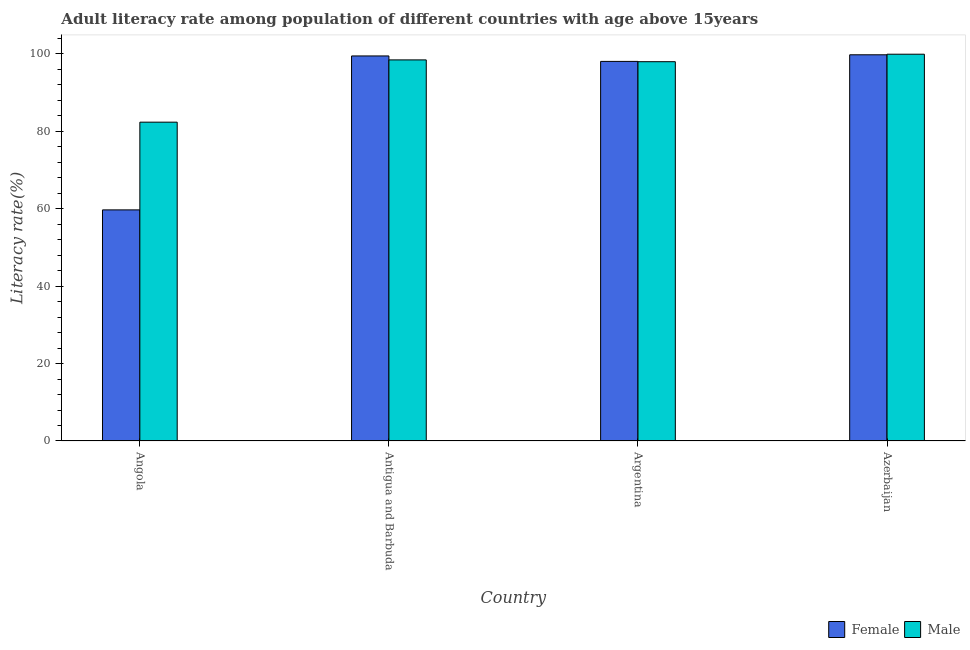How many different coloured bars are there?
Provide a succinct answer. 2. How many groups of bars are there?
Your answer should be very brief. 4. Are the number of bars on each tick of the X-axis equal?
Keep it short and to the point. Yes. How many bars are there on the 3rd tick from the right?
Your answer should be compact. 2. What is the label of the 4th group of bars from the left?
Make the answer very short. Azerbaijan. In how many cases, is the number of bars for a given country not equal to the number of legend labels?
Give a very brief answer. 0. What is the male adult literacy rate in Angola?
Make the answer very short. 82.32. Across all countries, what is the maximum male adult literacy rate?
Your answer should be very brief. 99.87. Across all countries, what is the minimum female adult literacy rate?
Make the answer very short. 59.67. In which country was the female adult literacy rate maximum?
Make the answer very short. Azerbaijan. In which country was the female adult literacy rate minimum?
Give a very brief answer. Angola. What is the total female adult literacy rate in the graph?
Provide a succinct answer. 356.82. What is the difference between the female adult literacy rate in Angola and that in Azerbaijan?
Give a very brief answer. -40.05. What is the difference between the female adult literacy rate in Angola and the male adult literacy rate in Azerbaijan?
Your answer should be very brief. -40.19. What is the average female adult literacy rate per country?
Offer a terse response. 89.21. What is the difference between the female adult literacy rate and male adult literacy rate in Angola?
Offer a terse response. -22.65. What is the ratio of the male adult literacy rate in Antigua and Barbuda to that in Argentina?
Provide a succinct answer. 1. Is the male adult literacy rate in Angola less than that in Argentina?
Make the answer very short. Yes. Is the difference between the female adult literacy rate in Angola and Azerbaijan greater than the difference between the male adult literacy rate in Angola and Azerbaijan?
Make the answer very short. No. What is the difference between the highest and the second highest male adult literacy rate?
Your answer should be very brief. 1.47. What is the difference between the highest and the lowest male adult literacy rate?
Your answer should be very brief. 17.54. Is the sum of the female adult literacy rate in Argentina and Azerbaijan greater than the maximum male adult literacy rate across all countries?
Provide a short and direct response. Yes. What does the 2nd bar from the left in Angola represents?
Provide a short and direct response. Male. What does the 1st bar from the right in Argentina represents?
Your answer should be very brief. Male. How many bars are there?
Your answer should be very brief. 8. Are all the bars in the graph horizontal?
Offer a terse response. No. Does the graph contain any zero values?
Your answer should be very brief. No. Does the graph contain grids?
Ensure brevity in your answer.  No. Where does the legend appear in the graph?
Your response must be concise. Bottom right. How many legend labels are there?
Your answer should be very brief. 2. What is the title of the graph?
Ensure brevity in your answer.  Adult literacy rate among population of different countries with age above 15years. Does "Non-solid fuel" appear as one of the legend labels in the graph?
Make the answer very short. No. What is the label or title of the Y-axis?
Your response must be concise. Literacy rate(%). What is the Literacy rate(%) of Female in Angola?
Your answer should be very brief. 59.67. What is the Literacy rate(%) in Male in Angola?
Your response must be concise. 82.32. What is the Literacy rate(%) of Female in Antigua and Barbuda?
Offer a terse response. 99.42. What is the Literacy rate(%) of Male in Antigua and Barbuda?
Make the answer very short. 98.4. What is the Literacy rate(%) in Female in Argentina?
Your answer should be compact. 98.01. What is the Literacy rate(%) in Male in Argentina?
Provide a succinct answer. 97.93. What is the Literacy rate(%) of Female in Azerbaijan?
Keep it short and to the point. 99.72. What is the Literacy rate(%) of Male in Azerbaijan?
Your answer should be compact. 99.87. Across all countries, what is the maximum Literacy rate(%) in Female?
Your response must be concise. 99.72. Across all countries, what is the maximum Literacy rate(%) of Male?
Provide a succinct answer. 99.87. Across all countries, what is the minimum Literacy rate(%) of Female?
Keep it short and to the point. 59.67. Across all countries, what is the minimum Literacy rate(%) of Male?
Offer a terse response. 82.32. What is the total Literacy rate(%) of Female in the graph?
Give a very brief answer. 356.82. What is the total Literacy rate(%) of Male in the graph?
Offer a very short reply. 378.52. What is the difference between the Literacy rate(%) in Female in Angola and that in Antigua and Barbuda?
Provide a succinct answer. -39.75. What is the difference between the Literacy rate(%) of Male in Angola and that in Antigua and Barbuda?
Offer a very short reply. -16.08. What is the difference between the Literacy rate(%) in Female in Angola and that in Argentina?
Your answer should be compact. -38.34. What is the difference between the Literacy rate(%) of Male in Angola and that in Argentina?
Keep it short and to the point. -15.61. What is the difference between the Literacy rate(%) of Female in Angola and that in Azerbaijan?
Your answer should be compact. -40.05. What is the difference between the Literacy rate(%) in Male in Angola and that in Azerbaijan?
Offer a terse response. -17.54. What is the difference between the Literacy rate(%) of Female in Antigua and Barbuda and that in Argentina?
Offer a very short reply. 1.41. What is the difference between the Literacy rate(%) of Male in Antigua and Barbuda and that in Argentina?
Your response must be concise. 0.47. What is the difference between the Literacy rate(%) in Female in Antigua and Barbuda and that in Azerbaijan?
Your response must be concise. -0.3. What is the difference between the Literacy rate(%) of Male in Antigua and Barbuda and that in Azerbaijan?
Offer a terse response. -1.47. What is the difference between the Literacy rate(%) in Female in Argentina and that in Azerbaijan?
Offer a very short reply. -1.71. What is the difference between the Literacy rate(%) in Male in Argentina and that in Azerbaijan?
Keep it short and to the point. -1.93. What is the difference between the Literacy rate(%) of Female in Angola and the Literacy rate(%) of Male in Antigua and Barbuda?
Make the answer very short. -38.73. What is the difference between the Literacy rate(%) of Female in Angola and the Literacy rate(%) of Male in Argentina?
Keep it short and to the point. -38.26. What is the difference between the Literacy rate(%) of Female in Angola and the Literacy rate(%) of Male in Azerbaijan?
Provide a short and direct response. -40.19. What is the difference between the Literacy rate(%) in Female in Antigua and Barbuda and the Literacy rate(%) in Male in Argentina?
Make the answer very short. 1.49. What is the difference between the Literacy rate(%) in Female in Antigua and Barbuda and the Literacy rate(%) in Male in Azerbaijan?
Provide a succinct answer. -0.45. What is the difference between the Literacy rate(%) of Female in Argentina and the Literacy rate(%) of Male in Azerbaijan?
Provide a succinct answer. -1.85. What is the average Literacy rate(%) in Female per country?
Ensure brevity in your answer.  89.2. What is the average Literacy rate(%) in Male per country?
Offer a terse response. 94.63. What is the difference between the Literacy rate(%) in Female and Literacy rate(%) in Male in Angola?
Provide a succinct answer. -22.65. What is the difference between the Literacy rate(%) of Female and Literacy rate(%) of Male in Argentina?
Make the answer very short. 0.08. What is the difference between the Literacy rate(%) in Female and Literacy rate(%) in Male in Azerbaijan?
Keep it short and to the point. -0.15. What is the ratio of the Literacy rate(%) in Female in Angola to that in Antigua and Barbuda?
Ensure brevity in your answer.  0.6. What is the ratio of the Literacy rate(%) of Male in Angola to that in Antigua and Barbuda?
Give a very brief answer. 0.84. What is the ratio of the Literacy rate(%) in Female in Angola to that in Argentina?
Provide a short and direct response. 0.61. What is the ratio of the Literacy rate(%) in Male in Angola to that in Argentina?
Ensure brevity in your answer.  0.84. What is the ratio of the Literacy rate(%) of Female in Angola to that in Azerbaijan?
Provide a succinct answer. 0.6. What is the ratio of the Literacy rate(%) of Male in Angola to that in Azerbaijan?
Your answer should be compact. 0.82. What is the ratio of the Literacy rate(%) of Female in Antigua and Barbuda to that in Argentina?
Make the answer very short. 1.01. What is the ratio of the Literacy rate(%) of Male in Antigua and Barbuda to that in Argentina?
Offer a terse response. 1. What is the ratio of the Literacy rate(%) in Female in Antigua and Barbuda to that in Azerbaijan?
Your answer should be compact. 1. What is the ratio of the Literacy rate(%) in Male in Antigua and Barbuda to that in Azerbaijan?
Offer a terse response. 0.99. What is the ratio of the Literacy rate(%) of Female in Argentina to that in Azerbaijan?
Keep it short and to the point. 0.98. What is the ratio of the Literacy rate(%) of Male in Argentina to that in Azerbaijan?
Give a very brief answer. 0.98. What is the difference between the highest and the second highest Literacy rate(%) of Female?
Offer a terse response. 0.3. What is the difference between the highest and the second highest Literacy rate(%) in Male?
Your response must be concise. 1.47. What is the difference between the highest and the lowest Literacy rate(%) in Female?
Provide a short and direct response. 40.05. What is the difference between the highest and the lowest Literacy rate(%) of Male?
Give a very brief answer. 17.54. 